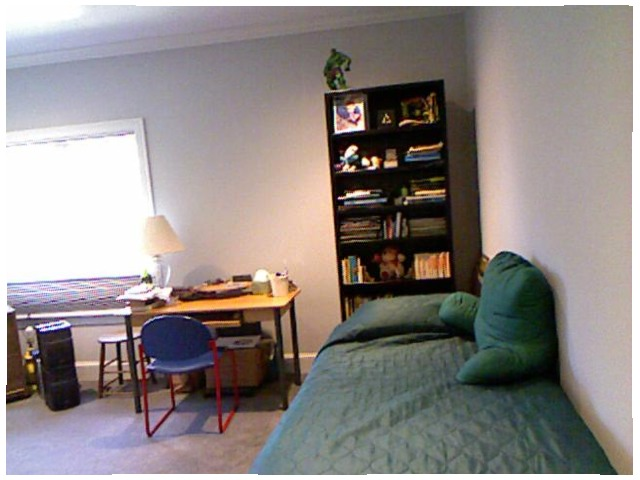<image>
Can you confirm if the book is on the shelf? Yes. Looking at the image, I can see the book is positioned on top of the shelf, with the shelf providing support. Where is the pillow in relation to the bed? Is it on the bed? Yes. Looking at the image, I can see the pillow is positioned on top of the bed, with the bed providing support. Is the book on the bed? No. The book is not positioned on the bed. They may be near each other, but the book is not supported by or resting on top of the bed. Where is the lamp in relation to the floor? Is it on the floor? No. The lamp is not positioned on the floor. They may be near each other, but the lamp is not supported by or resting on top of the floor. Is there a book on the desk? No. The book is not positioned on the desk. They may be near each other, but the book is not supported by or resting on top of the desk. Is the light in the window? Yes. The light is contained within or inside the window, showing a containment relationship. Is the pillow behind the bed? No. The pillow is not behind the bed. From this viewpoint, the pillow appears to be positioned elsewhere in the scene. 